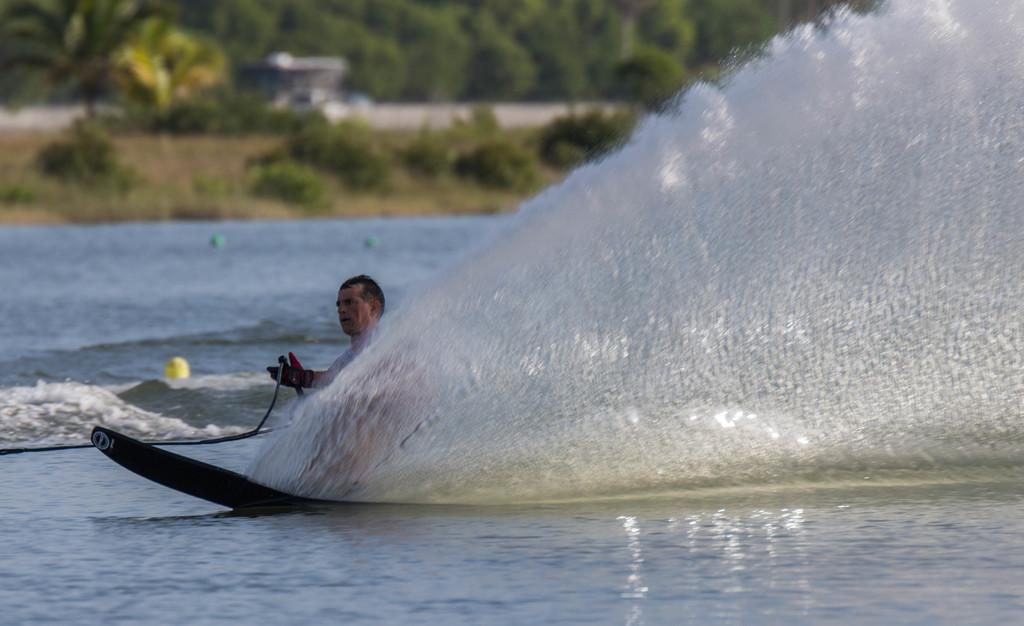Who is the main subject in the image? There is a man in the image. What is the man doing in the image? The man is wakeboarding on the water surface. What can be seen in the background of the image? There are many trees visible in the image. What type of flower can be seen on the man's wakeboard in the image? There are no flowers present on the man's wakeboard in the image. 